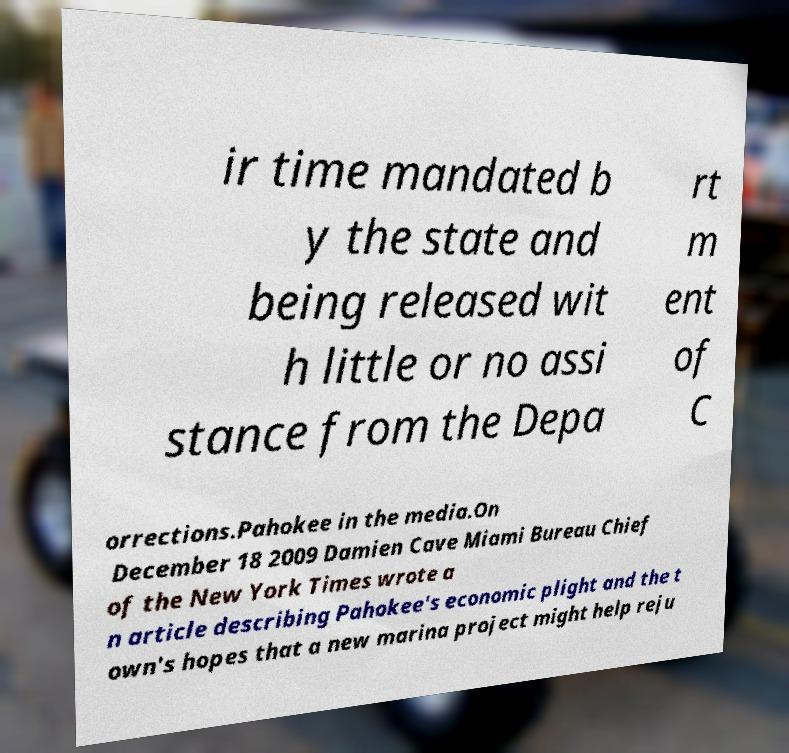Can you accurately transcribe the text from the provided image for me? ir time mandated b y the state and being released wit h little or no assi stance from the Depa rt m ent of C orrections.Pahokee in the media.On December 18 2009 Damien Cave Miami Bureau Chief of the New York Times wrote a n article describing Pahokee's economic plight and the t own's hopes that a new marina project might help reju 